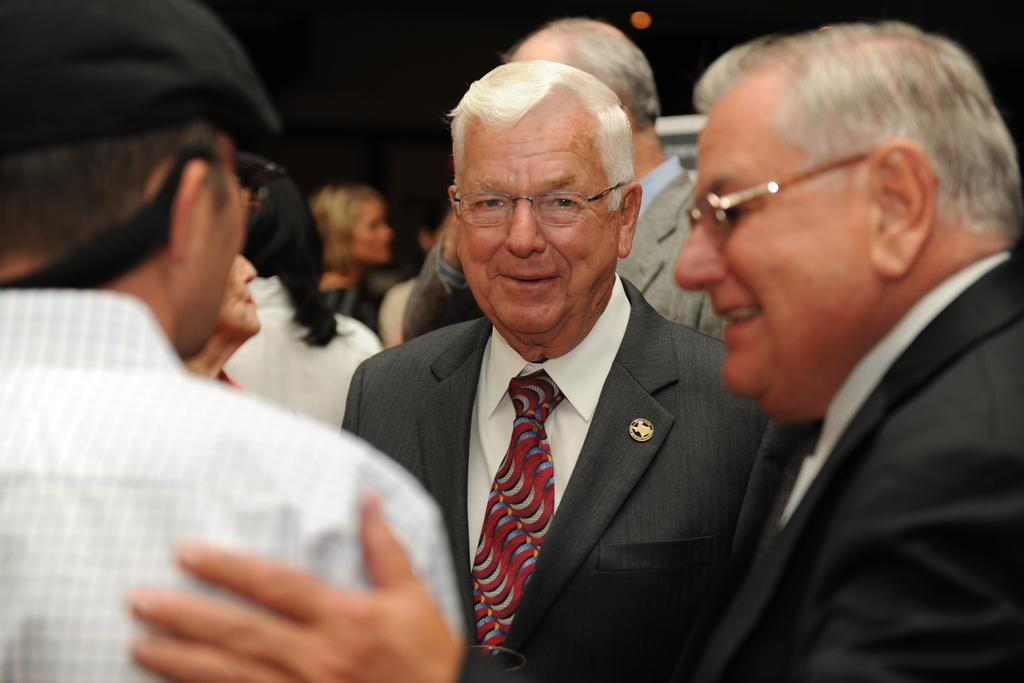Who is the main subject in the image? There is an old man in the image. Where is the old man located in the image? The old man is standing in the center of the image. Are there any other people present in the image? Yes, there are other people in the image. What type of scent can be detected from the old man in the image? There is no information about the scent of the old man in the image, so it cannot be determined. 